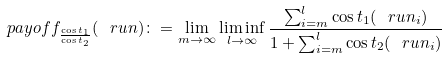<formula> <loc_0><loc_0><loc_500><loc_500>\ p a y o f f _ { \frac { \cos t _ { 1 } } { \cos t _ { 2 } } } ( \ r u n ) \colon = \lim _ { m \to \infty } \liminf _ { l \to \infty } \frac { \sum _ { i = m } ^ { l } \cos t _ { 1 } ( \ r u n _ { i } ) } { 1 + \sum _ { i = m } ^ { l } \cos t _ { 2 } ( \ r u n _ { i } ) }</formula> 